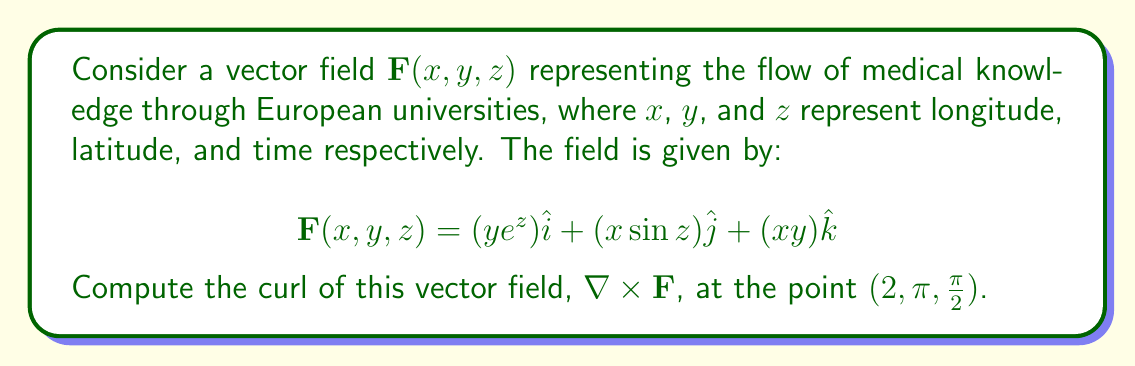What is the answer to this math problem? To compute the curl of the vector field, we use the formula:

$$\nabla \times \mathbf{F} = \left(\frac{\partial F_z}{\partial y} - \frac{\partial F_y}{\partial z}\right)\hat{i} + \left(\frac{\partial F_x}{\partial z} - \frac{\partial F_z}{\partial x}\right)\hat{j} + \left(\frac{\partial F_y}{\partial x} - \frac{\partial F_x}{\partial y}\right)\hat{k}$$

Let's calculate each component:

1) $\frac{\partial F_z}{\partial y} - \frac{\partial F_y}{\partial z}$:
   $\frac{\partial F_z}{\partial y} = \frac{\partial (xy)}{\partial y} = x$
   $\frac{\partial F_y}{\partial z} = \frac{\partial (x\sin z)}{\partial z} = x\cos z$
   $\frac{\partial F_z}{\partial y} - \frac{\partial F_y}{\partial z} = x - x\cos z$

2) $\frac{\partial F_x}{\partial z} - \frac{\partial F_z}{\partial x}$:
   $\frac{\partial F_x}{\partial z} = \frac{\partial (ye^z)}{\partial z} = ye^z$
   $\frac{\partial F_z}{\partial x} = \frac{\partial (xy)}{\partial x} = y$
   $\frac{\partial F_x}{\partial z} - \frac{\partial F_z}{\partial x} = ye^z - y$

3) $\frac{\partial F_y}{\partial x} - \frac{\partial F_x}{\partial y}$:
   $\frac{\partial F_y}{\partial x} = \frac{\partial (x\sin z)}{\partial x} = \sin z$
   $\frac{\partial F_x}{\partial y} = \frac{\partial (ye^z)}{\partial y} = e^z$
   $\frac{\partial F_y}{\partial x} - \frac{\partial F_x}{\partial y} = \sin z - e^z$

Therefore, the curl is:

$$\nabla \times \mathbf{F} = (x - x\cos z)\hat{i} + (ye^z - y)\hat{j} + (\sin z - e^z)\hat{k}$$

At the point $(2, \pi, \frac{\pi}{2})$:

$$\nabla \times \mathbf{F}(2, \pi, \frac{\pi}{2}) = (2 - 2\cos \frac{\pi}{2})\hat{i} + (\pi e^{\frac{\pi}{2}} - \pi)\hat{j} + (\sin \frac{\pi}{2} - e^{\frac{\pi}{2}})\hat{k}$$

Simplifying:

$$\nabla \times \mathbf{F}(2, \pi, \frac{\pi}{2}) = 2\hat{i} + \pi(e^{\frac{\pi}{2}} - 1)\hat{j} + (1 - e^{\frac{\pi}{2}})\hat{k}$$
Answer: $2\hat{i} + \pi(e^{\frac{\pi}{2}} - 1)\hat{j} + (1 - e^{\frac{\pi}{2}})\hat{k}$ 